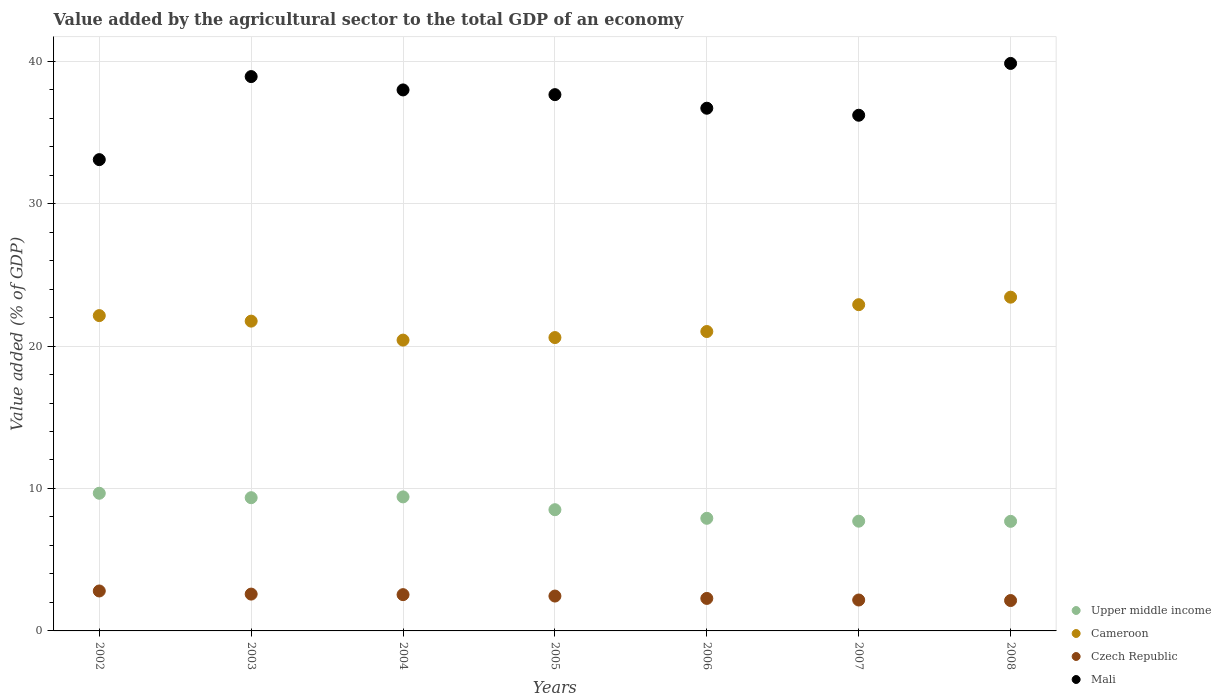How many different coloured dotlines are there?
Give a very brief answer. 4. What is the value added by the agricultural sector to the total GDP in Czech Republic in 2004?
Offer a terse response. 2.55. Across all years, what is the maximum value added by the agricultural sector to the total GDP in Czech Republic?
Give a very brief answer. 2.8. Across all years, what is the minimum value added by the agricultural sector to the total GDP in Mali?
Ensure brevity in your answer.  33.09. In which year was the value added by the agricultural sector to the total GDP in Mali maximum?
Make the answer very short. 2008. What is the total value added by the agricultural sector to the total GDP in Cameroon in the graph?
Keep it short and to the point. 152.25. What is the difference between the value added by the agricultural sector to the total GDP in Czech Republic in 2002 and that in 2008?
Your answer should be very brief. 0.67. What is the difference between the value added by the agricultural sector to the total GDP in Cameroon in 2006 and the value added by the agricultural sector to the total GDP in Mali in 2004?
Give a very brief answer. -16.96. What is the average value added by the agricultural sector to the total GDP in Czech Republic per year?
Provide a succinct answer. 2.42. In the year 2008, what is the difference between the value added by the agricultural sector to the total GDP in Upper middle income and value added by the agricultural sector to the total GDP in Mali?
Keep it short and to the point. -32.15. What is the ratio of the value added by the agricultural sector to the total GDP in Cameroon in 2002 to that in 2006?
Offer a terse response. 1.05. What is the difference between the highest and the second highest value added by the agricultural sector to the total GDP in Upper middle income?
Keep it short and to the point. 0.25. What is the difference between the highest and the lowest value added by the agricultural sector to the total GDP in Czech Republic?
Your answer should be compact. 0.67. Does the value added by the agricultural sector to the total GDP in Czech Republic monotonically increase over the years?
Your answer should be very brief. No. What is the difference between two consecutive major ticks on the Y-axis?
Your answer should be very brief. 10. Does the graph contain any zero values?
Your answer should be very brief. No. What is the title of the graph?
Provide a short and direct response. Value added by the agricultural sector to the total GDP of an economy. Does "Russian Federation" appear as one of the legend labels in the graph?
Give a very brief answer. No. What is the label or title of the X-axis?
Your answer should be very brief. Years. What is the label or title of the Y-axis?
Ensure brevity in your answer.  Value added (% of GDP). What is the Value added (% of GDP) of Upper middle income in 2002?
Your answer should be very brief. 9.66. What is the Value added (% of GDP) of Cameroon in 2002?
Provide a succinct answer. 22.14. What is the Value added (% of GDP) of Czech Republic in 2002?
Your response must be concise. 2.8. What is the Value added (% of GDP) of Mali in 2002?
Provide a short and direct response. 33.09. What is the Value added (% of GDP) of Upper middle income in 2003?
Ensure brevity in your answer.  9.35. What is the Value added (% of GDP) of Cameroon in 2003?
Ensure brevity in your answer.  21.75. What is the Value added (% of GDP) in Czech Republic in 2003?
Keep it short and to the point. 2.59. What is the Value added (% of GDP) of Mali in 2003?
Ensure brevity in your answer.  38.92. What is the Value added (% of GDP) of Upper middle income in 2004?
Provide a succinct answer. 9.41. What is the Value added (% of GDP) of Cameroon in 2004?
Keep it short and to the point. 20.42. What is the Value added (% of GDP) of Czech Republic in 2004?
Give a very brief answer. 2.55. What is the Value added (% of GDP) in Mali in 2004?
Keep it short and to the point. 37.98. What is the Value added (% of GDP) in Upper middle income in 2005?
Make the answer very short. 8.51. What is the Value added (% of GDP) of Cameroon in 2005?
Your answer should be very brief. 20.59. What is the Value added (% of GDP) of Czech Republic in 2005?
Your response must be concise. 2.45. What is the Value added (% of GDP) of Mali in 2005?
Keep it short and to the point. 37.65. What is the Value added (% of GDP) of Upper middle income in 2006?
Your response must be concise. 7.91. What is the Value added (% of GDP) in Cameroon in 2006?
Offer a very short reply. 21.02. What is the Value added (% of GDP) of Czech Republic in 2006?
Ensure brevity in your answer.  2.28. What is the Value added (% of GDP) in Mali in 2006?
Provide a short and direct response. 36.7. What is the Value added (% of GDP) of Upper middle income in 2007?
Keep it short and to the point. 7.7. What is the Value added (% of GDP) of Cameroon in 2007?
Give a very brief answer. 22.9. What is the Value added (% of GDP) in Czech Republic in 2007?
Offer a terse response. 2.17. What is the Value added (% of GDP) of Mali in 2007?
Offer a very short reply. 36.2. What is the Value added (% of GDP) in Upper middle income in 2008?
Offer a terse response. 7.69. What is the Value added (% of GDP) of Cameroon in 2008?
Offer a terse response. 23.43. What is the Value added (% of GDP) of Czech Republic in 2008?
Your response must be concise. 2.13. What is the Value added (% of GDP) in Mali in 2008?
Keep it short and to the point. 39.84. Across all years, what is the maximum Value added (% of GDP) in Upper middle income?
Your answer should be compact. 9.66. Across all years, what is the maximum Value added (% of GDP) in Cameroon?
Keep it short and to the point. 23.43. Across all years, what is the maximum Value added (% of GDP) in Czech Republic?
Offer a very short reply. 2.8. Across all years, what is the maximum Value added (% of GDP) in Mali?
Your response must be concise. 39.84. Across all years, what is the minimum Value added (% of GDP) in Upper middle income?
Give a very brief answer. 7.69. Across all years, what is the minimum Value added (% of GDP) of Cameroon?
Make the answer very short. 20.42. Across all years, what is the minimum Value added (% of GDP) of Czech Republic?
Your answer should be very brief. 2.13. Across all years, what is the minimum Value added (% of GDP) in Mali?
Provide a succinct answer. 33.09. What is the total Value added (% of GDP) of Upper middle income in the graph?
Provide a succinct answer. 60.24. What is the total Value added (% of GDP) in Cameroon in the graph?
Provide a succinct answer. 152.25. What is the total Value added (% of GDP) of Czech Republic in the graph?
Provide a succinct answer. 16.97. What is the total Value added (% of GDP) in Mali in the graph?
Give a very brief answer. 260.37. What is the difference between the Value added (% of GDP) of Upper middle income in 2002 and that in 2003?
Ensure brevity in your answer.  0.31. What is the difference between the Value added (% of GDP) in Cameroon in 2002 and that in 2003?
Keep it short and to the point. 0.39. What is the difference between the Value added (% of GDP) of Czech Republic in 2002 and that in 2003?
Your answer should be compact. 0.22. What is the difference between the Value added (% of GDP) of Mali in 2002 and that in 2003?
Keep it short and to the point. -5.83. What is the difference between the Value added (% of GDP) of Upper middle income in 2002 and that in 2004?
Your response must be concise. 0.25. What is the difference between the Value added (% of GDP) in Cameroon in 2002 and that in 2004?
Your response must be concise. 1.72. What is the difference between the Value added (% of GDP) of Czech Republic in 2002 and that in 2004?
Offer a terse response. 0.26. What is the difference between the Value added (% of GDP) of Mali in 2002 and that in 2004?
Give a very brief answer. -4.89. What is the difference between the Value added (% of GDP) in Upper middle income in 2002 and that in 2005?
Provide a short and direct response. 1.15. What is the difference between the Value added (% of GDP) in Cameroon in 2002 and that in 2005?
Offer a terse response. 1.54. What is the difference between the Value added (% of GDP) in Czech Republic in 2002 and that in 2005?
Provide a short and direct response. 0.36. What is the difference between the Value added (% of GDP) in Mali in 2002 and that in 2005?
Provide a short and direct response. -4.56. What is the difference between the Value added (% of GDP) of Upper middle income in 2002 and that in 2006?
Provide a succinct answer. 1.76. What is the difference between the Value added (% of GDP) in Cameroon in 2002 and that in 2006?
Ensure brevity in your answer.  1.12. What is the difference between the Value added (% of GDP) of Czech Republic in 2002 and that in 2006?
Offer a very short reply. 0.52. What is the difference between the Value added (% of GDP) of Mali in 2002 and that in 2006?
Offer a very short reply. -3.61. What is the difference between the Value added (% of GDP) in Upper middle income in 2002 and that in 2007?
Offer a terse response. 1.96. What is the difference between the Value added (% of GDP) of Cameroon in 2002 and that in 2007?
Offer a terse response. -0.77. What is the difference between the Value added (% of GDP) of Czech Republic in 2002 and that in 2007?
Your response must be concise. 0.63. What is the difference between the Value added (% of GDP) of Mali in 2002 and that in 2007?
Provide a short and direct response. -3.12. What is the difference between the Value added (% of GDP) in Upper middle income in 2002 and that in 2008?
Make the answer very short. 1.97. What is the difference between the Value added (% of GDP) of Cameroon in 2002 and that in 2008?
Ensure brevity in your answer.  -1.29. What is the difference between the Value added (% of GDP) of Czech Republic in 2002 and that in 2008?
Offer a terse response. 0.67. What is the difference between the Value added (% of GDP) of Mali in 2002 and that in 2008?
Your answer should be very brief. -6.75. What is the difference between the Value added (% of GDP) in Upper middle income in 2003 and that in 2004?
Provide a succinct answer. -0.06. What is the difference between the Value added (% of GDP) in Cameroon in 2003 and that in 2004?
Your response must be concise. 1.33. What is the difference between the Value added (% of GDP) in Czech Republic in 2003 and that in 2004?
Your answer should be compact. 0.04. What is the difference between the Value added (% of GDP) in Mali in 2003 and that in 2004?
Ensure brevity in your answer.  0.94. What is the difference between the Value added (% of GDP) of Upper middle income in 2003 and that in 2005?
Offer a terse response. 0.84. What is the difference between the Value added (% of GDP) in Cameroon in 2003 and that in 2005?
Your response must be concise. 1.15. What is the difference between the Value added (% of GDP) in Czech Republic in 2003 and that in 2005?
Offer a terse response. 0.14. What is the difference between the Value added (% of GDP) of Mali in 2003 and that in 2005?
Ensure brevity in your answer.  1.27. What is the difference between the Value added (% of GDP) in Upper middle income in 2003 and that in 2006?
Your answer should be compact. 1.45. What is the difference between the Value added (% of GDP) of Cameroon in 2003 and that in 2006?
Offer a terse response. 0.73. What is the difference between the Value added (% of GDP) of Czech Republic in 2003 and that in 2006?
Keep it short and to the point. 0.3. What is the difference between the Value added (% of GDP) in Mali in 2003 and that in 2006?
Your answer should be very brief. 2.22. What is the difference between the Value added (% of GDP) in Upper middle income in 2003 and that in 2007?
Keep it short and to the point. 1.65. What is the difference between the Value added (% of GDP) of Cameroon in 2003 and that in 2007?
Make the answer very short. -1.15. What is the difference between the Value added (% of GDP) in Czech Republic in 2003 and that in 2007?
Your answer should be very brief. 0.41. What is the difference between the Value added (% of GDP) of Mali in 2003 and that in 2007?
Offer a terse response. 2.71. What is the difference between the Value added (% of GDP) in Upper middle income in 2003 and that in 2008?
Your response must be concise. 1.66. What is the difference between the Value added (% of GDP) of Cameroon in 2003 and that in 2008?
Your answer should be compact. -1.68. What is the difference between the Value added (% of GDP) of Czech Republic in 2003 and that in 2008?
Provide a short and direct response. 0.45. What is the difference between the Value added (% of GDP) of Mali in 2003 and that in 2008?
Offer a terse response. -0.92. What is the difference between the Value added (% of GDP) in Upper middle income in 2004 and that in 2005?
Ensure brevity in your answer.  0.9. What is the difference between the Value added (% of GDP) in Cameroon in 2004 and that in 2005?
Your answer should be compact. -0.18. What is the difference between the Value added (% of GDP) of Czech Republic in 2004 and that in 2005?
Your answer should be very brief. 0.1. What is the difference between the Value added (% of GDP) of Mali in 2004 and that in 2005?
Your answer should be compact. 0.33. What is the difference between the Value added (% of GDP) in Upper middle income in 2004 and that in 2006?
Make the answer very short. 1.5. What is the difference between the Value added (% of GDP) of Cameroon in 2004 and that in 2006?
Offer a very short reply. -0.6. What is the difference between the Value added (% of GDP) in Czech Republic in 2004 and that in 2006?
Your answer should be very brief. 0.26. What is the difference between the Value added (% of GDP) of Mali in 2004 and that in 2006?
Offer a very short reply. 1.28. What is the difference between the Value added (% of GDP) in Upper middle income in 2004 and that in 2007?
Provide a short and direct response. 1.71. What is the difference between the Value added (% of GDP) in Cameroon in 2004 and that in 2007?
Your response must be concise. -2.49. What is the difference between the Value added (% of GDP) of Czech Republic in 2004 and that in 2007?
Make the answer very short. 0.38. What is the difference between the Value added (% of GDP) in Mali in 2004 and that in 2007?
Your response must be concise. 1.78. What is the difference between the Value added (% of GDP) in Upper middle income in 2004 and that in 2008?
Provide a short and direct response. 1.72. What is the difference between the Value added (% of GDP) in Cameroon in 2004 and that in 2008?
Your answer should be compact. -3.01. What is the difference between the Value added (% of GDP) in Czech Republic in 2004 and that in 2008?
Your response must be concise. 0.41. What is the difference between the Value added (% of GDP) in Mali in 2004 and that in 2008?
Offer a terse response. -1.86. What is the difference between the Value added (% of GDP) in Upper middle income in 2005 and that in 2006?
Offer a very short reply. 0.6. What is the difference between the Value added (% of GDP) of Cameroon in 2005 and that in 2006?
Your response must be concise. -0.42. What is the difference between the Value added (% of GDP) of Czech Republic in 2005 and that in 2006?
Provide a succinct answer. 0.17. What is the difference between the Value added (% of GDP) in Mali in 2005 and that in 2006?
Keep it short and to the point. 0.95. What is the difference between the Value added (% of GDP) in Upper middle income in 2005 and that in 2007?
Make the answer very short. 0.81. What is the difference between the Value added (% of GDP) in Cameroon in 2005 and that in 2007?
Give a very brief answer. -2.31. What is the difference between the Value added (% of GDP) of Czech Republic in 2005 and that in 2007?
Your answer should be very brief. 0.28. What is the difference between the Value added (% of GDP) in Mali in 2005 and that in 2007?
Ensure brevity in your answer.  1.45. What is the difference between the Value added (% of GDP) of Upper middle income in 2005 and that in 2008?
Provide a short and direct response. 0.82. What is the difference between the Value added (% of GDP) in Cameroon in 2005 and that in 2008?
Offer a very short reply. -2.84. What is the difference between the Value added (% of GDP) of Czech Republic in 2005 and that in 2008?
Make the answer very short. 0.31. What is the difference between the Value added (% of GDP) in Mali in 2005 and that in 2008?
Provide a short and direct response. -2.19. What is the difference between the Value added (% of GDP) in Upper middle income in 2006 and that in 2007?
Provide a succinct answer. 0.2. What is the difference between the Value added (% of GDP) of Cameroon in 2006 and that in 2007?
Your answer should be very brief. -1.88. What is the difference between the Value added (% of GDP) in Czech Republic in 2006 and that in 2007?
Make the answer very short. 0.11. What is the difference between the Value added (% of GDP) of Mali in 2006 and that in 2007?
Keep it short and to the point. 0.49. What is the difference between the Value added (% of GDP) in Upper middle income in 2006 and that in 2008?
Your answer should be very brief. 0.21. What is the difference between the Value added (% of GDP) of Cameroon in 2006 and that in 2008?
Give a very brief answer. -2.41. What is the difference between the Value added (% of GDP) of Czech Republic in 2006 and that in 2008?
Your answer should be compact. 0.15. What is the difference between the Value added (% of GDP) of Mali in 2006 and that in 2008?
Provide a succinct answer. -3.14. What is the difference between the Value added (% of GDP) in Upper middle income in 2007 and that in 2008?
Your response must be concise. 0.01. What is the difference between the Value added (% of GDP) of Cameroon in 2007 and that in 2008?
Offer a very short reply. -0.53. What is the difference between the Value added (% of GDP) of Czech Republic in 2007 and that in 2008?
Offer a very short reply. 0.04. What is the difference between the Value added (% of GDP) in Mali in 2007 and that in 2008?
Keep it short and to the point. -3.64. What is the difference between the Value added (% of GDP) of Upper middle income in 2002 and the Value added (% of GDP) of Cameroon in 2003?
Offer a terse response. -12.08. What is the difference between the Value added (% of GDP) of Upper middle income in 2002 and the Value added (% of GDP) of Czech Republic in 2003?
Make the answer very short. 7.08. What is the difference between the Value added (% of GDP) in Upper middle income in 2002 and the Value added (% of GDP) in Mali in 2003?
Provide a succinct answer. -29.25. What is the difference between the Value added (% of GDP) in Cameroon in 2002 and the Value added (% of GDP) in Czech Republic in 2003?
Ensure brevity in your answer.  19.55. What is the difference between the Value added (% of GDP) of Cameroon in 2002 and the Value added (% of GDP) of Mali in 2003?
Provide a short and direct response. -16.78. What is the difference between the Value added (% of GDP) in Czech Republic in 2002 and the Value added (% of GDP) in Mali in 2003?
Offer a very short reply. -36.11. What is the difference between the Value added (% of GDP) in Upper middle income in 2002 and the Value added (% of GDP) in Cameroon in 2004?
Provide a succinct answer. -10.75. What is the difference between the Value added (% of GDP) of Upper middle income in 2002 and the Value added (% of GDP) of Czech Republic in 2004?
Provide a succinct answer. 7.12. What is the difference between the Value added (% of GDP) of Upper middle income in 2002 and the Value added (% of GDP) of Mali in 2004?
Provide a succinct answer. -28.32. What is the difference between the Value added (% of GDP) of Cameroon in 2002 and the Value added (% of GDP) of Czech Republic in 2004?
Make the answer very short. 19.59. What is the difference between the Value added (% of GDP) of Cameroon in 2002 and the Value added (% of GDP) of Mali in 2004?
Your answer should be very brief. -15.84. What is the difference between the Value added (% of GDP) of Czech Republic in 2002 and the Value added (% of GDP) of Mali in 2004?
Your answer should be very brief. -35.18. What is the difference between the Value added (% of GDP) in Upper middle income in 2002 and the Value added (% of GDP) in Cameroon in 2005?
Offer a very short reply. -10.93. What is the difference between the Value added (% of GDP) in Upper middle income in 2002 and the Value added (% of GDP) in Czech Republic in 2005?
Offer a very short reply. 7.22. What is the difference between the Value added (% of GDP) in Upper middle income in 2002 and the Value added (% of GDP) in Mali in 2005?
Ensure brevity in your answer.  -27.98. What is the difference between the Value added (% of GDP) of Cameroon in 2002 and the Value added (% of GDP) of Czech Republic in 2005?
Your answer should be very brief. 19.69. What is the difference between the Value added (% of GDP) in Cameroon in 2002 and the Value added (% of GDP) in Mali in 2005?
Offer a very short reply. -15.51. What is the difference between the Value added (% of GDP) of Czech Republic in 2002 and the Value added (% of GDP) of Mali in 2005?
Your answer should be compact. -34.85. What is the difference between the Value added (% of GDP) of Upper middle income in 2002 and the Value added (% of GDP) of Cameroon in 2006?
Offer a very short reply. -11.35. What is the difference between the Value added (% of GDP) of Upper middle income in 2002 and the Value added (% of GDP) of Czech Republic in 2006?
Keep it short and to the point. 7.38. What is the difference between the Value added (% of GDP) in Upper middle income in 2002 and the Value added (% of GDP) in Mali in 2006?
Provide a succinct answer. -27.03. What is the difference between the Value added (% of GDP) in Cameroon in 2002 and the Value added (% of GDP) in Czech Republic in 2006?
Offer a very short reply. 19.85. What is the difference between the Value added (% of GDP) of Cameroon in 2002 and the Value added (% of GDP) of Mali in 2006?
Offer a terse response. -14.56. What is the difference between the Value added (% of GDP) of Czech Republic in 2002 and the Value added (% of GDP) of Mali in 2006?
Keep it short and to the point. -33.89. What is the difference between the Value added (% of GDP) in Upper middle income in 2002 and the Value added (% of GDP) in Cameroon in 2007?
Give a very brief answer. -13.24. What is the difference between the Value added (% of GDP) in Upper middle income in 2002 and the Value added (% of GDP) in Czech Republic in 2007?
Provide a succinct answer. 7.49. What is the difference between the Value added (% of GDP) of Upper middle income in 2002 and the Value added (% of GDP) of Mali in 2007?
Your answer should be compact. -26.54. What is the difference between the Value added (% of GDP) in Cameroon in 2002 and the Value added (% of GDP) in Czech Republic in 2007?
Your response must be concise. 19.97. What is the difference between the Value added (% of GDP) in Cameroon in 2002 and the Value added (% of GDP) in Mali in 2007?
Give a very brief answer. -14.07. What is the difference between the Value added (% of GDP) in Czech Republic in 2002 and the Value added (% of GDP) in Mali in 2007?
Ensure brevity in your answer.  -33.4. What is the difference between the Value added (% of GDP) in Upper middle income in 2002 and the Value added (% of GDP) in Cameroon in 2008?
Give a very brief answer. -13.77. What is the difference between the Value added (% of GDP) of Upper middle income in 2002 and the Value added (% of GDP) of Czech Republic in 2008?
Keep it short and to the point. 7.53. What is the difference between the Value added (% of GDP) in Upper middle income in 2002 and the Value added (% of GDP) in Mali in 2008?
Keep it short and to the point. -30.18. What is the difference between the Value added (% of GDP) of Cameroon in 2002 and the Value added (% of GDP) of Czech Republic in 2008?
Your response must be concise. 20. What is the difference between the Value added (% of GDP) in Cameroon in 2002 and the Value added (% of GDP) in Mali in 2008?
Make the answer very short. -17.7. What is the difference between the Value added (% of GDP) of Czech Republic in 2002 and the Value added (% of GDP) of Mali in 2008?
Make the answer very short. -37.04. What is the difference between the Value added (% of GDP) of Upper middle income in 2003 and the Value added (% of GDP) of Cameroon in 2004?
Ensure brevity in your answer.  -11.06. What is the difference between the Value added (% of GDP) in Upper middle income in 2003 and the Value added (% of GDP) in Czech Republic in 2004?
Offer a terse response. 6.81. What is the difference between the Value added (% of GDP) of Upper middle income in 2003 and the Value added (% of GDP) of Mali in 2004?
Give a very brief answer. -28.63. What is the difference between the Value added (% of GDP) in Cameroon in 2003 and the Value added (% of GDP) in Czech Republic in 2004?
Offer a very short reply. 19.2. What is the difference between the Value added (% of GDP) in Cameroon in 2003 and the Value added (% of GDP) in Mali in 2004?
Provide a succinct answer. -16.23. What is the difference between the Value added (% of GDP) of Czech Republic in 2003 and the Value added (% of GDP) of Mali in 2004?
Offer a terse response. -35.39. What is the difference between the Value added (% of GDP) of Upper middle income in 2003 and the Value added (% of GDP) of Cameroon in 2005?
Your response must be concise. -11.24. What is the difference between the Value added (% of GDP) of Upper middle income in 2003 and the Value added (% of GDP) of Czech Republic in 2005?
Give a very brief answer. 6.91. What is the difference between the Value added (% of GDP) in Upper middle income in 2003 and the Value added (% of GDP) in Mali in 2005?
Make the answer very short. -28.3. What is the difference between the Value added (% of GDP) in Cameroon in 2003 and the Value added (% of GDP) in Czech Republic in 2005?
Give a very brief answer. 19.3. What is the difference between the Value added (% of GDP) of Cameroon in 2003 and the Value added (% of GDP) of Mali in 2005?
Keep it short and to the point. -15.9. What is the difference between the Value added (% of GDP) of Czech Republic in 2003 and the Value added (% of GDP) of Mali in 2005?
Offer a very short reply. -35.06. What is the difference between the Value added (% of GDP) in Upper middle income in 2003 and the Value added (% of GDP) in Cameroon in 2006?
Your answer should be very brief. -11.67. What is the difference between the Value added (% of GDP) in Upper middle income in 2003 and the Value added (% of GDP) in Czech Republic in 2006?
Provide a short and direct response. 7.07. What is the difference between the Value added (% of GDP) of Upper middle income in 2003 and the Value added (% of GDP) of Mali in 2006?
Ensure brevity in your answer.  -27.34. What is the difference between the Value added (% of GDP) of Cameroon in 2003 and the Value added (% of GDP) of Czech Republic in 2006?
Offer a very short reply. 19.47. What is the difference between the Value added (% of GDP) in Cameroon in 2003 and the Value added (% of GDP) in Mali in 2006?
Make the answer very short. -14.95. What is the difference between the Value added (% of GDP) in Czech Republic in 2003 and the Value added (% of GDP) in Mali in 2006?
Your response must be concise. -34.11. What is the difference between the Value added (% of GDP) in Upper middle income in 2003 and the Value added (% of GDP) in Cameroon in 2007?
Your answer should be compact. -13.55. What is the difference between the Value added (% of GDP) in Upper middle income in 2003 and the Value added (% of GDP) in Czech Republic in 2007?
Keep it short and to the point. 7.18. What is the difference between the Value added (% of GDP) in Upper middle income in 2003 and the Value added (% of GDP) in Mali in 2007?
Offer a very short reply. -26.85. What is the difference between the Value added (% of GDP) in Cameroon in 2003 and the Value added (% of GDP) in Czech Republic in 2007?
Give a very brief answer. 19.58. What is the difference between the Value added (% of GDP) of Cameroon in 2003 and the Value added (% of GDP) of Mali in 2007?
Your response must be concise. -14.45. What is the difference between the Value added (% of GDP) of Czech Republic in 2003 and the Value added (% of GDP) of Mali in 2007?
Your answer should be compact. -33.62. What is the difference between the Value added (% of GDP) in Upper middle income in 2003 and the Value added (% of GDP) in Cameroon in 2008?
Your answer should be compact. -14.08. What is the difference between the Value added (% of GDP) of Upper middle income in 2003 and the Value added (% of GDP) of Czech Republic in 2008?
Offer a very short reply. 7.22. What is the difference between the Value added (% of GDP) in Upper middle income in 2003 and the Value added (% of GDP) in Mali in 2008?
Offer a very short reply. -30.49. What is the difference between the Value added (% of GDP) in Cameroon in 2003 and the Value added (% of GDP) in Czech Republic in 2008?
Provide a short and direct response. 19.62. What is the difference between the Value added (% of GDP) in Cameroon in 2003 and the Value added (% of GDP) in Mali in 2008?
Make the answer very short. -18.09. What is the difference between the Value added (% of GDP) in Czech Republic in 2003 and the Value added (% of GDP) in Mali in 2008?
Your response must be concise. -37.26. What is the difference between the Value added (% of GDP) in Upper middle income in 2004 and the Value added (% of GDP) in Cameroon in 2005?
Your answer should be very brief. -11.18. What is the difference between the Value added (% of GDP) of Upper middle income in 2004 and the Value added (% of GDP) of Czech Republic in 2005?
Make the answer very short. 6.96. What is the difference between the Value added (% of GDP) in Upper middle income in 2004 and the Value added (% of GDP) in Mali in 2005?
Your response must be concise. -28.24. What is the difference between the Value added (% of GDP) of Cameroon in 2004 and the Value added (% of GDP) of Czech Republic in 2005?
Offer a terse response. 17.97. What is the difference between the Value added (% of GDP) of Cameroon in 2004 and the Value added (% of GDP) of Mali in 2005?
Keep it short and to the point. -17.23. What is the difference between the Value added (% of GDP) of Czech Republic in 2004 and the Value added (% of GDP) of Mali in 2005?
Make the answer very short. -35.1. What is the difference between the Value added (% of GDP) in Upper middle income in 2004 and the Value added (% of GDP) in Cameroon in 2006?
Make the answer very short. -11.61. What is the difference between the Value added (% of GDP) of Upper middle income in 2004 and the Value added (% of GDP) of Czech Republic in 2006?
Your answer should be compact. 7.13. What is the difference between the Value added (% of GDP) of Upper middle income in 2004 and the Value added (% of GDP) of Mali in 2006?
Ensure brevity in your answer.  -27.29. What is the difference between the Value added (% of GDP) of Cameroon in 2004 and the Value added (% of GDP) of Czech Republic in 2006?
Offer a terse response. 18.13. What is the difference between the Value added (% of GDP) of Cameroon in 2004 and the Value added (% of GDP) of Mali in 2006?
Ensure brevity in your answer.  -16.28. What is the difference between the Value added (% of GDP) in Czech Republic in 2004 and the Value added (% of GDP) in Mali in 2006?
Your answer should be compact. -34.15. What is the difference between the Value added (% of GDP) of Upper middle income in 2004 and the Value added (% of GDP) of Cameroon in 2007?
Make the answer very short. -13.49. What is the difference between the Value added (% of GDP) of Upper middle income in 2004 and the Value added (% of GDP) of Czech Republic in 2007?
Provide a short and direct response. 7.24. What is the difference between the Value added (% of GDP) of Upper middle income in 2004 and the Value added (% of GDP) of Mali in 2007?
Make the answer very short. -26.79. What is the difference between the Value added (% of GDP) of Cameroon in 2004 and the Value added (% of GDP) of Czech Republic in 2007?
Your response must be concise. 18.25. What is the difference between the Value added (% of GDP) of Cameroon in 2004 and the Value added (% of GDP) of Mali in 2007?
Provide a succinct answer. -15.79. What is the difference between the Value added (% of GDP) in Czech Republic in 2004 and the Value added (% of GDP) in Mali in 2007?
Ensure brevity in your answer.  -33.66. What is the difference between the Value added (% of GDP) in Upper middle income in 2004 and the Value added (% of GDP) in Cameroon in 2008?
Offer a terse response. -14.02. What is the difference between the Value added (% of GDP) of Upper middle income in 2004 and the Value added (% of GDP) of Czech Republic in 2008?
Your answer should be very brief. 7.28. What is the difference between the Value added (% of GDP) in Upper middle income in 2004 and the Value added (% of GDP) in Mali in 2008?
Make the answer very short. -30.43. What is the difference between the Value added (% of GDP) of Cameroon in 2004 and the Value added (% of GDP) of Czech Republic in 2008?
Provide a succinct answer. 18.28. What is the difference between the Value added (% of GDP) of Cameroon in 2004 and the Value added (% of GDP) of Mali in 2008?
Offer a terse response. -19.42. What is the difference between the Value added (% of GDP) in Czech Republic in 2004 and the Value added (% of GDP) in Mali in 2008?
Give a very brief answer. -37.29. What is the difference between the Value added (% of GDP) in Upper middle income in 2005 and the Value added (% of GDP) in Cameroon in 2006?
Ensure brevity in your answer.  -12.51. What is the difference between the Value added (% of GDP) of Upper middle income in 2005 and the Value added (% of GDP) of Czech Republic in 2006?
Provide a short and direct response. 6.23. What is the difference between the Value added (% of GDP) of Upper middle income in 2005 and the Value added (% of GDP) of Mali in 2006?
Make the answer very short. -28.19. What is the difference between the Value added (% of GDP) in Cameroon in 2005 and the Value added (% of GDP) in Czech Republic in 2006?
Give a very brief answer. 18.31. What is the difference between the Value added (% of GDP) in Cameroon in 2005 and the Value added (% of GDP) in Mali in 2006?
Give a very brief answer. -16.1. What is the difference between the Value added (% of GDP) in Czech Republic in 2005 and the Value added (% of GDP) in Mali in 2006?
Your answer should be compact. -34.25. What is the difference between the Value added (% of GDP) in Upper middle income in 2005 and the Value added (% of GDP) in Cameroon in 2007?
Keep it short and to the point. -14.39. What is the difference between the Value added (% of GDP) of Upper middle income in 2005 and the Value added (% of GDP) of Czech Republic in 2007?
Your answer should be compact. 6.34. What is the difference between the Value added (% of GDP) of Upper middle income in 2005 and the Value added (% of GDP) of Mali in 2007?
Your answer should be very brief. -27.69. What is the difference between the Value added (% of GDP) of Cameroon in 2005 and the Value added (% of GDP) of Czech Republic in 2007?
Offer a very short reply. 18.42. What is the difference between the Value added (% of GDP) in Cameroon in 2005 and the Value added (% of GDP) in Mali in 2007?
Keep it short and to the point. -15.61. What is the difference between the Value added (% of GDP) of Czech Republic in 2005 and the Value added (% of GDP) of Mali in 2007?
Keep it short and to the point. -33.75. What is the difference between the Value added (% of GDP) in Upper middle income in 2005 and the Value added (% of GDP) in Cameroon in 2008?
Provide a short and direct response. -14.92. What is the difference between the Value added (% of GDP) of Upper middle income in 2005 and the Value added (% of GDP) of Czech Republic in 2008?
Keep it short and to the point. 6.38. What is the difference between the Value added (% of GDP) in Upper middle income in 2005 and the Value added (% of GDP) in Mali in 2008?
Give a very brief answer. -31.33. What is the difference between the Value added (% of GDP) of Cameroon in 2005 and the Value added (% of GDP) of Czech Republic in 2008?
Your response must be concise. 18.46. What is the difference between the Value added (% of GDP) of Cameroon in 2005 and the Value added (% of GDP) of Mali in 2008?
Provide a succinct answer. -19.25. What is the difference between the Value added (% of GDP) of Czech Republic in 2005 and the Value added (% of GDP) of Mali in 2008?
Make the answer very short. -37.39. What is the difference between the Value added (% of GDP) of Upper middle income in 2006 and the Value added (% of GDP) of Cameroon in 2007?
Your response must be concise. -15. What is the difference between the Value added (% of GDP) in Upper middle income in 2006 and the Value added (% of GDP) in Czech Republic in 2007?
Keep it short and to the point. 5.74. What is the difference between the Value added (% of GDP) in Upper middle income in 2006 and the Value added (% of GDP) in Mali in 2007?
Keep it short and to the point. -28.3. What is the difference between the Value added (% of GDP) in Cameroon in 2006 and the Value added (% of GDP) in Czech Republic in 2007?
Provide a short and direct response. 18.85. What is the difference between the Value added (% of GDP) of Cameroon in 2006 and the Value added (% of GDP) of Mali in 2007?
Keep it short and to the point. -15.18. What is the difference between the Value added (% of GDP) of Czech Republic in 2006 and the Value added (% of GDP) of Mali in 2007?
Keep it short and to the point. -33.92. What is the difference between the Value added (% of GDP) in Upper middle income in 2006 and the Value added (% of GDP) in Cameroon in 2008?
Your answer should be very brief. -15.52. What is the difference between the Value added (% of GDP) of Upper middle income in 2006 and the Value added (% of GDP) of Czech Republic in 2008?
Offer a very short reply. 5.77. What is the difference between the Value added (% of GDP) in Upper middle income in 2006 and the Value added (% of GDP) in Mali in 2008?
Your answer should be very brief. -31.93. What is the difference between the Value added (% of GDP) of Cameroon in 2006 and the Value added (% of GDP) of Czech Republic in 2008?
Your response must be concise. 18.89. What is the difference between the Value added (% of GDP) in Cameroon in 2006 and the Value added (% of GDP) in Mali in 2008?
Make the answer very short. -18.82. What is the difference between the Value added (% of GDP) in Czech Republic in 2006 and the Value added (% of GDP) in Mali in 2008?
Your answer should be very brief. -37.56. What is the difference between the Value added (% of GDP) of Upper middle income in 2007 and the Value added (% of GDP) of Cameroon in 2008?
Keep it short and to the point. -15.73. What is the difference between the Value added (% of GDP) in Upper middle income in 2007 and the Value added (% of GDP) in Czech Republic in 2008?
Provide a short and direct response. 5.57. What is the difference between the Value added (% of GDP) in Upper middle income in 2007 and the Value added (% of GDP) in Mali in 2008?
Keep it short and to the point. -32.14. What is the difference between the Value added (% of GDP) in Cameroon in 2007 and the Value added (% of GDP) in Czech Republic in 2008?
Your answer should be compact. 20.77. What is the difference between the Value added (% of GDP) of Cameroon in 2007 and the Value added (% of GDP) of Mali in 2008?
Give a very brief answer. -16.94. What is the difference between the Value added (% of GDP) in Czech Republic in 2007 and the Value added (% of GDP) in Mali in 2008?
Offer a terse response. -37.67. What is the average Value added (% of GDP) in Upper middle income per year?
Provide a short and direct response. 8.61. What is the average Value added (% of GDP) in Cameroon per year?
Your answer should be very brief. 21.75. What is the average Value added (% of GDP) in Czech Republic per year?
Make the answer very short. 2.42. What is the average Value added (% of GDP) in Mali per year?
Offer a very short reply. 37.2. In the year 2002, what is the difference between the Value added (% of GDP) of Upper middle income and Value added (% of GDP) of Cameroon?
Offer a terse response. -12.47. In the year 2002, what is the difference between the Value added (% of GDP) in Upper middle income and Value added (% of GDP) in Czech Republic?
Make the answer very short. 6.86. In the year 2002, what is the difference between the Value added (% of GDP) in Upper middle income and Value added (% of GDP) in Mali?
Offer a very short reply. -23.42. In the year 2002, what is the difference between the Value added (% of GDP) in Cameroon and Value added (% of GDP) in Czech Republic?
Your answer should be very brief. 19.33. In the year 2002, what is the difference between the Value added (% of GDP) of Cameroon and Value added (% of GDP) of Mali?
Your response must be concise. -10.95. In the year 2002, what is the difference between the Value added (% of GDP) in Czech Republic and Value added (% of GDP) in Mali?
Offer a terse response. -30.28. In the year 2003, what is the difference between the Value added (% of GDP) in Upper middle income and Value added (% of GDP) in Cameroon?
Make the answer very short. -12.4. In the year 2003, what is the difference between the Value added (% of GDP) of Upper middle income and Value added (% of GDP) of Czech Republic?
Offer a very short reply. 6.77. In the year 2003, what is the difference between the Value added (% of GDP) in Upper middle income and Value added (% of GDP) in Mali?
Keep it short and to the point. -29.56. In the year 2003, what is the difference between the Value added (% of GDP) in Cameroon and Value added (% of GDP) in Czech Republic?
Offer a terse response. 19.16. In the year 2003, what is the difference between the Value added (% of GDP) in Cameroon and Value added (% of GDP) in Mali?
Offer a very short reply. -17.17. In the year 2003, what is the difference between the Value added (% of GDP) of Czech Republic and Value added (% of GDP) of Mali?
Provide a short and direct response. -36.33. In the year 2004, what is the difference between the Value added (% of GDP) in Upper middle income and Value added (% of GDP) in Cameroon?
Offer a terse response. -11.01. In the year 2004, what is the difference between the Value added (% of GDP) of Upper middle income and Value added (% of GDP) of Czech Republic?
Offer a terse response. 6.86. In the year 2004, what is the difference between the Value added (% of GDP) in Upper middle income and Value added (% of GDP) in Mali?
Offer a very short reply. -28.57. In the year 2004, what is the difference between the Value added (% of GDP) of Cameroon and Value added (% of GDP) of Czech Republic?
Give a very brief answer. 17.87. In the year 2004, what is the difference between the Value added (% of GDP) of Cameroon and Value added (% of GDP) of Mali?
Provide a succinct answer. -17.56. In the year 2004, what is the difference between the Value added (% of GDP) of Czech Republic and Value added (% of GDP) of Mali?
Provide a succinct answer. -35.43. In the year 2005, what is the difference between the Value added (% of GDP) in Upper middle income and Value added (% of GDP) in Cameroon?
Your answer should be very brief. -12.08. In the year 2005, what is the difference between the Value added (% of GDP) of Upper middle income and Value added (% of GDP) of Czech Republic?
Keep it short and to the point. 6.06. In the year 2005, what is the difference between the Value added (% of GDP) of Upper middle income and Value added (% of GDP) of Mali?
Give a very brief answer. -29.14. In the year 2005, what is the difference between the Value added (% of GDP) in Cameroon and Value added (% of GDP) in Czech Republic?
Offer a very short reply. 18.15. In the year 2005, what is the difference between the Value added (% of GDP) of Cameroon and Value added (% of GDP) of Mali?
Offer a terse response. -17.05. In the year 2005, what is the difference between the Value added (% of GDP) of Czech Republic and Value added (% of GDP) of Mali?
Your answer should be compact. -35.2. In the year 2006, what is the difference between the Value added (% of GDP) of Upper middle income and Value added (% of GDP) of Cameroon?
Offer a terse response. -13.11. In the year 2006, what is the difference between the Value added (% of GDP) of Upper middle income and Value added (% of GDP) of Czech Republic?
Provide a short and direct response. 5.62. In the year 2006, what is the difference between the Value added (% of GDP) in Upper middle income and Value added (% of GDP) in Mali?
Provide a short and direct response. -28.79. In the year 2006, what is the difference between the Value added (% of GDP) in Cameroon and Value added (% of GDP) in Czech Republic?
Ensure brevity in your answer.  18.74. In the year 2006, what is the difference between the Value added (% of GDP) in Cameroon and Value added (% of GDP) in Mali?
Make the answer very short. -15.68. In the year 2006, what is the difference between the Value added (% of GDP) in Czech Republic and Value added (% of GDP) in Mali?
Offer a terse response. -34.41. In the year 2007, what is the difference between the Value added (% of GDP) in Upper middle income and Value added (% of GDP) in Cameroon?
Your response must be concise. -15.2. In the year 2007, what is the difference between the Value added (% of GDP) in Upper middle income and Value added (% of GDP) in Czech Republic?
Give a very brief answer. 5.53. In the year 2007, what is the difference between the Value added (% of GDP) of Upper middle income and Value added (% of GDP) of Mali?
Give a very brief answer. -28.5. In the year 2007, what is the difference between the Value added (% of GDP) of Cameroon and Value added (% of GDP) of Czech Republic?
Keep it short and to the point. 20.73. In the year 2007, what is the difference between the Value added (% of GDP) in Cameroon and Value added (% of GDP) in Mali?
Provide a succinct answer. -13.3. In the year 2007, what is the difference between the Value added (% of GDP) in Czech Republic and Value added (% of GDP) in Mali?
Give a very brief answer. -34.03. In the year 2008, what is the difference between the Value added (% of GDP) in Upper middle income and Value added (% of GDP) in Cameroon?
Ensure brevity in your answer.  -15.74. In the year 2008, what is the difference between the Value added (% of GDP) in Upper middle income and Value added (% of GDP) in Czech Republic?
Provide a succinct answer. 5.56. In the year 2008, what is the difference between the Value added (% of GDP) in Upper middle income and Value added (% of GDP) in Mali?
Offer a very short reply. -32.15. In the year 2008, what is the difference between the Value added (% of GDP) in Cameroon and Value added (% of GDP) in Czech Republic?
Offer a terse response. 21.3. In the year 2008, what is the difference between the Value added (% of GDP) of Cameroon and Value added (% of GDP) of Mali?
Make the answer very short. -16.41. In the year 2008, what is the difference between the Value added (% of GDP) of Czech Republic and Value added (% of GDP) of Mali?
Provide a short and direct response. -37.71. What is the ratio of the Value added (% of GDP) of Upper middle income in 2002 to that in 2003?
Make the answer very short. 1.03. What is the ratio of the Value added (% of GDP) in Cameroon in 2002 to that in 2003?
Your response must be concise. 1.02. What is the ratio of the Value added (% of GDP) of Czech Republic in 2002 to that in 2003?
Offer a very short reply. 1.08. What is the ratio of the Value added (% of GDP) in Mali in 2002 to that in 2003?
Ensure brevity in your answer.  0.85. What is the ratio of the Value added (% of GDP) of Upper middle income in 2002 to that in 2004?
Offer a terse response. 1.03. What is the ratio of the Value added (% of GDP) of Cameroon in 2002 to that in 2004?
Ensure brevity in your answer.  1.08. What is the ratio of the Value added (% of GDP) of Czech Republic in 2002 to that in 2004?
Provide a short and direct response. 1.1. What is the ratio of the Value added (% of GDP) of Mali in 2002 to that in 2004?
Your answer should be compact. 0.87. What is the ratio of the Value added (% of GDP) in Upper middle income in 2002 to that in 2005?
Ensure brevity in your answer.  1.14. What is the ratio of the Value added (% of GDP) in Cameroon in 2002 to that in 2005?
Your answer should be very brief. 1.07. What is the ratio of the Value added (% of GDP) in Czech Republic in 2002 to that in 2005?
Provide a succinct answer. 1.15. What is the ratio of the Value added (% of GDP) of Mali in 2002 to that in 2005?
Offer a terse response. 0.88. What is the ratio of the Value added (% of GDP) of Upper middle income in 2002 to that in 2006?
Provide a succinct answer. 1.22. What is the ratio of the Value added (% of GDP) of Cameroon in 2002 to that in 2006?
Your response must be concise. 1.05. What is the ratio of the Value added (% of GDP) of Czech Republic in 2002 to that in 2006?
Your answer should be compact. 1.23. What is the ratio of the Value added (% of GDP) of Mali in 2002 to that in 2006?
Provide a succinct answer. 0.9. What is the ratio of the Value added (% of GDP) of Upper middle income in 2002 to that in 2007?
Your answer should be very brief. 1.25. What is the ratio of the Value added (% of GDP) in Cameroon in 2002 to that in 2007?
Your response must be concise. 0.97. What is the ratio of the Value added (% of GDP) in Czech Republic in 2002 to that in 2007?
Keep it short and to the point. 1.29. What is the ratio of the Value added (% of GDP) in Mali in 2002 to that in 2007?
Offer a terse response. 0.91. What is the ratio of the Value added (% of GDP) of Upper middle income in 2002 to that in 2008?
Your response must be concise. 1.26. What is the ratio of the Value added (% of GDP) of Cameroon in 2002 to that in 2008?
Your answer should be compact. 0.94. What is the ratio of the Value added (% of GDP) in Czech Republic in 2002 to that in 2008?
Provide a short and direct response. 1.31. What is the ratio of the Value added (% of GDP) in Mali in 2002 to that in 2008?
Keep it short and to the point. 0.83. What is the ratio of the Value added (% of GDP) in Cameroon in 2003 to that in 2004?
Ensure brevity in your answer.  1.07. What is the ratio of the Value added (% of GDP) of Czech Republic in 2003 to that in 2004?
Your answer should be compact. 1.02. What is the ratio of the Value added (% of GDP) of Mali in 2003 to that in 2004?
Give a very brief answer. 1.02. What is the ratio of the Value added (% of GDP) in Upper middle income in 2003 to that in 2005?
Your answer should be compact. 1.1. What is the ratio of the Value added (% of GDP) of Cameroon in 2003 to that in 2005?
Give a very brief answer. 1.06. What is the ratio of the Value added (% of GDP) of Czech Republic in 2003 to that in 2005?
Provide a short and direct response. 1.06. What is the ratio of the Value added (% of GDP) of Mali in 2003 to that in 2005?
Your response must be concise. 1.03. What is the ratio of the Value added (% of GDP) in Upper middle income in 2003 to that in 2006?
Offer a terse response. 1.18. What is the ratio of the Value added (% of GDP) in Cameroon in 2003 to that in 2006?
Provide a short and direct response. 1.03. What is the ratio of the Value added (% of GDP) of Czech Republic in 2003 to that in 2006?
Provide a short and direct response. 1.13. What is the ratio of the Value added (% of GDP) of Mali in 2003 to that in 2006?
Keep it short and to the point. 1.06. What is the ratio of the Value added (% of GDP) of Upper middle income in 2003 to that in 2007?
Provide a short and direct response. 1.21. What is the ratio of the Value added (% of GDP) of Cameroon in 2003 to that in 2007?
Provide a short and direct response. 0.95. What is the ratio of the Value added (% of GDP) of Czech Republic in 2003 to that in 2007?
Your response must be concise. 1.19. What is the ratio of the Value added (% of GDP) in Mali in 2003 to that in 2007?
Ensure brevity in your answer.  1.07. What is the ratio of the Value added (% of GDP) in Upper middle income in 2003 to that in 2008?
Your answer should be compact. 1.22. What is the ratio of the Value added (% of GDP) in Cameroon in 2003 to that in 2008?
Your answer should be very brief. 0.93. What is the ratio of the Value added (% of GDP) in Czech Republic in 2003 to that in 2008?
Offer a very short reply. 1.21. What is the ratio of the Value added (% of GDP) of Mali in 2003 to that in 2008?
Make the answer very short. 0.98. What is the ratio of the Value added (% of GDP) of Upper middle income in 2004 to that in 2005?
Make the answer very short. 1.11. What is the ratio of the Value added (% of GDP) of Czech Republic in 2004 to that in 2005?
Offer a terse response. 1.04. What is the ratio of the Value added (% of GDP) in Mali in 2004 to that in 2005?
Make the answer very short. 1.01. What is the ratio of the Value added (% of GDP) in Upper middle income in 2004 to that in 2006?
Ensure brevity in your answer.  1.19. What is the ratio of the Value added (% of GDP) in Cameroon in 2004 to that in 2006?
Your answer should be very brief. 0.97. What is the ratio of the Value added (% of GDP) in Czech Republic in 2004 to that in 2006?
Offer a very short reply. 1.12. What is the ratio of the Value added (% of GDP) of Mali in 2004 to that in 2006?
Give a very brief answer. 1.03. What is the ratio of the Value added (% of GDP) in Upper middle income in 2004 to that in 2007?
Your response must be concise. 1.22. What is the ratio of the Value added (% of GDP) in Cameroon in 2004 to that in 2007?
Offer a terse response. 0.89. What is the ratio of the Value added (% of GDP) in Czech Republic in 2004 to that in 2007?
Offer a terse response. 1.17. What is the ratio of the Value added (% of GDP) of Mali in 2004 to that in 2007?
Your response must be concise. 1.05. What is the ratio of the Value added (% of GDP) of Upper middle income in 2004 to that in 2008?
Ensure brevity in your answer.  1.22. What is the ratio of the Value added (% of GDP) in Cameroon in 2004 to that in 2008?
Your response must be concise. 0.87. What is the ratio of the Value added (% of GDP) in Czech Republic in 2004 to that in 2008?
Give a very brief answer. 1.19. What is the ratio of the Value added (% of GDP) in Mali in 2004 to that in 2008?
Provide a short and direct response. 0.95. What is the ratio of the Value added (% of GDP) of Upper middle income in 2005 to that in 2006?
Offer a terse response. 1.08. What is the ratio of the Value added (% of GDP) in Cameroon in 2005 to that in 2006?
Provide a succinct answer. 0.98. What is the ratio of the Value added (% of GDP) in Czech Republic in 2005 to that in 2006?
Keep it short and to the point. 1.07. What is the ratio of the Value added (% of GDP) of Upper middle income in 2005 to that in 2007?
Provide a succinct answer. 1.1. What is the ratio of the Value added (% of GDP) in Cameroon in 2005 to that in 2007?
Your answer should be compact. 0.9. What is the ratio of the Value added (% of GDP) in Czech Republic in 2005 to that in 2007?
Offer a very short reply. 1.13. What is the ratio of the Value added (% of GDP) in Upper middle income in 2005 to that in 2008?
Offer a terse response. 1.11. What is the ratio of the Value added (% of GDP) in Cameroon in 2005 to that in 2008?
Your answer should be compact. 0.88. What is the ratio of the Value added (% of GDP) of Czech Republic in 2005 to that in 2008?
Provide a succinct answer. 1.15. What is the ratio of the Value added (% of GDP) in Mali in 2005 to that in 2008?
Your answer should be very brief. 0.94. What is the ratio of the Value added (% of GDP) in Upper middle income in 2006 to that in 2007?
Make the answer very short. 1.03. What is the ratio of the Value added (% of GDP) of Cameroon in 2006 to that in 2007?
Offer a terse response. 0.92. What is the ratio of the Value added (% of GDP) in Czech Republic in 2006 to that in 2007?
Offer a terse response. 1.05. What is the ratio of the Value added (% of GDP) in Mali in 2006 to that in 2007?
Your response must be concise. 1.01. What is the ratio of the Value added (% of GDP) in Upper middle income in 2006 to that in 2008?
Your answer should be compact. 1.03. What is the ratio of the Value added (% of GDP) in Cameroon in 2006 to that in 2008?
Ensure brevity in your answer.  0.9. What is the ratio of the Value added (% of GDP) of Czech Republic in 2006 to that in 2008?
Your response must be concise. 1.07. What is the ratio of the Value added (% of GDP) of Mali in 2006 to that in 2008?
Your response must be concise. 0.92. What is the ratio of the Value added (% of GDP) of Upper middle income in 2007 to that in 2008?
Offer a terse response. 1. What is the ratio of the Value added (% of GDP) in Cameroon in 2007 to that in 2008?
Your answer should be very brief. 0.98. What is the ratio of the Value added (% of GDP) of Czech Republic in 2007 to that in 2008?
Your response must be concise. 1.02. What is the ratio of the Value added (% of GDP) of Mali in 2007 to that in 2008?
Give a very brief answer. 0.91. What is the difference between the highest and the second highest Value added (% of GDP) in Upper middle income?
Give a very brief answer. 0.25. What is the difference between the highest and the second highest Value added (% of GDP) of Cameroon?
Your answer should be very brief. 0.53. What is the difference between the highest and the second highest Value added (% of GDP) in Czech Republic?
Make the answer very short. 0.22. What is the difference between the highest and the second highest Value added (% of GDP) in Mali?
Make the answer very short. 0.92. What is the difference between the highest and the lowest Value added (% of GDP) of Upper middle income?
Provide a succinct answer. 1.97. What is the difference between the highest and the lowest Value added (% of GDP) in Cameroon?
Your answer should be compact. 3.01. What is the difference between the highest and the lowest Value added (% of GDP) of Czech Republic?
Keep it short and to the point. 0.67. What is the difference between the highest and the lowest Value added (% of GDP) in Mali?
Offer a very short reply. 6.75. 